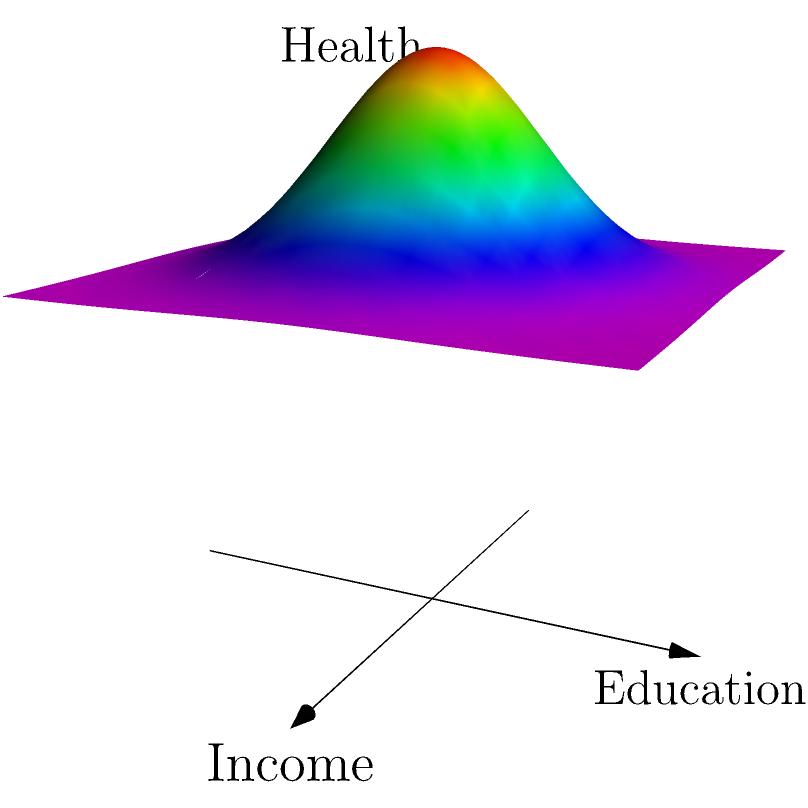The 3D surface plot represents the relationship between income (x-axis), education (y-axis), and health outcomes (z-axis) in a community. Given this visualization, which vector $\vec{v}$ would likely represent the direction of greatest improvement in health outcomes?

A) $\vec{v} = \langle 1, 0, 0 \rangle$
B) $\vec{v} = \langle 0, 1, 0 \rangle$
C) $\vec{v} = \langle 1, 1, 0 \rangle$
D) $\vec{v} = \langle -1, -1, 0 \rangle$ To determine the direction of greatest improvement in health outcomes, we need to analyze the 3D surface plot:

1. The z-axis represents health outcomes, with higher values indicating better health.
2. The peak of the surface is at the center, where both income and education are highest.
3. The surface slopes upward as we move towards higher income and higher education levels.

Step-by-step analysis:
1. $\vec{v} = \langle 1, 0, 0 \rangle$ represents movement along the income axis only. This would improve health outcomes but not maximize improvement.
2. $\vec{v} = \langle 0, 1, 0 \rangle$ represents movement along the education axis only. This would also improve health outcomes but not maximize improvement.
3. $\vec{v} = \langle 1, 1, 0 \rangle$ represents movement diagonally, increasing both income and education simultaneously. This direction aligns with the steepest ascent on the surface, leading to the greatest improvement in health outcomes.
4. $\vec{v} = \langle -1, -1, 0 \rangle$ represents movement away from the peak, which would worsen health outcomes.

Therefore, the vector that would likely represent the direction of greatest improvement in health outcomes is $\vec{v} = \langle 1, 1, 0 \rangle$.

This aligns with sociological research on health inequalities, which often demonstrates that improvements in both socioeconomic status (represented by income) and education level tend to have synergistic effects on health outcomes.
Answer: $\vec{v} = \langle 1, 1, 0 \rangle$ 